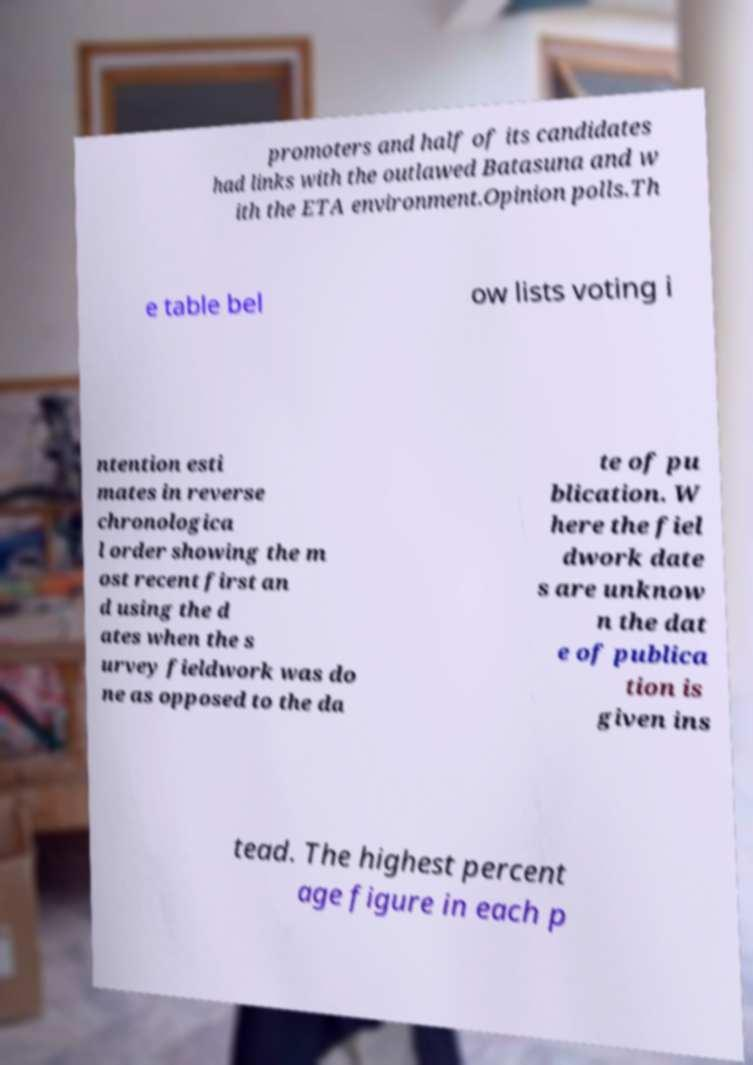What messages or text are displayed in this image? I need them in a readable, typed format. promoters and half of its candidates had links with the outlawed Batasuna and w ith the ETA environment.Opinion polls.Th e table bel ow lists voting i ntention esti mates in reverse chronologica l order showing the m ost recent first an d using the d ates when the s urvey fieldwork was do ne as opposed to the da te of pu blication. W here the fiel dwork date s are unknow n the dat e of publica tion is given ins tead. The highest percent age figure in each p 